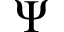Convert formula to latex. <formula><loc_0><loc_0><loc_500><loc_500>\Psi</formula> 